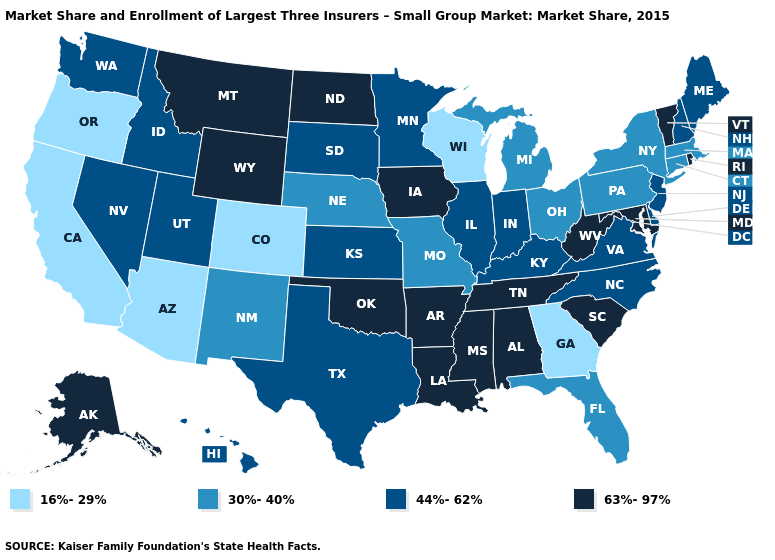Among the states that border Missouri , does Illinois have the highest value?
Keep it brief. No. What is the value of New Mexico?
Write a very short answer. 30%-40%. What is the lowest value in states that border Ohio?
Write a very short answer. 30%-40%. Among the states that border Utah , does Nevada have the highest value?
Answer briefly. No. Does Montana have the highest value in the West?
Short answer required. Yes. Which states hav the highest value in the South?
Quick response, please. Alabama, Arkansas, Louisiana, Maryland, Mississippi, Oklahoma, South Carolina, Tennessee, West Virginia. Does Massachusetts have the same value as South Dakota?
Concise answer only. No. Name the states that have a value in the range 16%-29%?
Be succinct. Arizona, California, Colorado, Georgia, Oregon, Wisconsin. What is the value of Kansas?
Answer briefly. 44%-62%. Which states have the lowest value in the USA?
Write a very short answer. Arizona, California, Colorado, Georgia, Oregon, Wisconsin. Among the states that border Utah , does Colorado have the lowest value?
Quick response, please. Yes. Does the map have missing data?
Quick response, please. No. Name the states that have a value in the range 63%-97%?
Quick response, please. Alabama, Alaska, Arkansas, Iowa, Louisiana, Maryland, Mississippi, Montana, North Dakota, Oklahoma, Rhode Island, South Carolina, Tennessee, Vermont, West Virginia, Wyoming. What is the value of West Virginia?
Be succinct. 63%-97%. Which states have the lowest value in the USA?
Concise answer only. Arizona, California, Colorado, Georgia, Oregon, Wisconsin. 